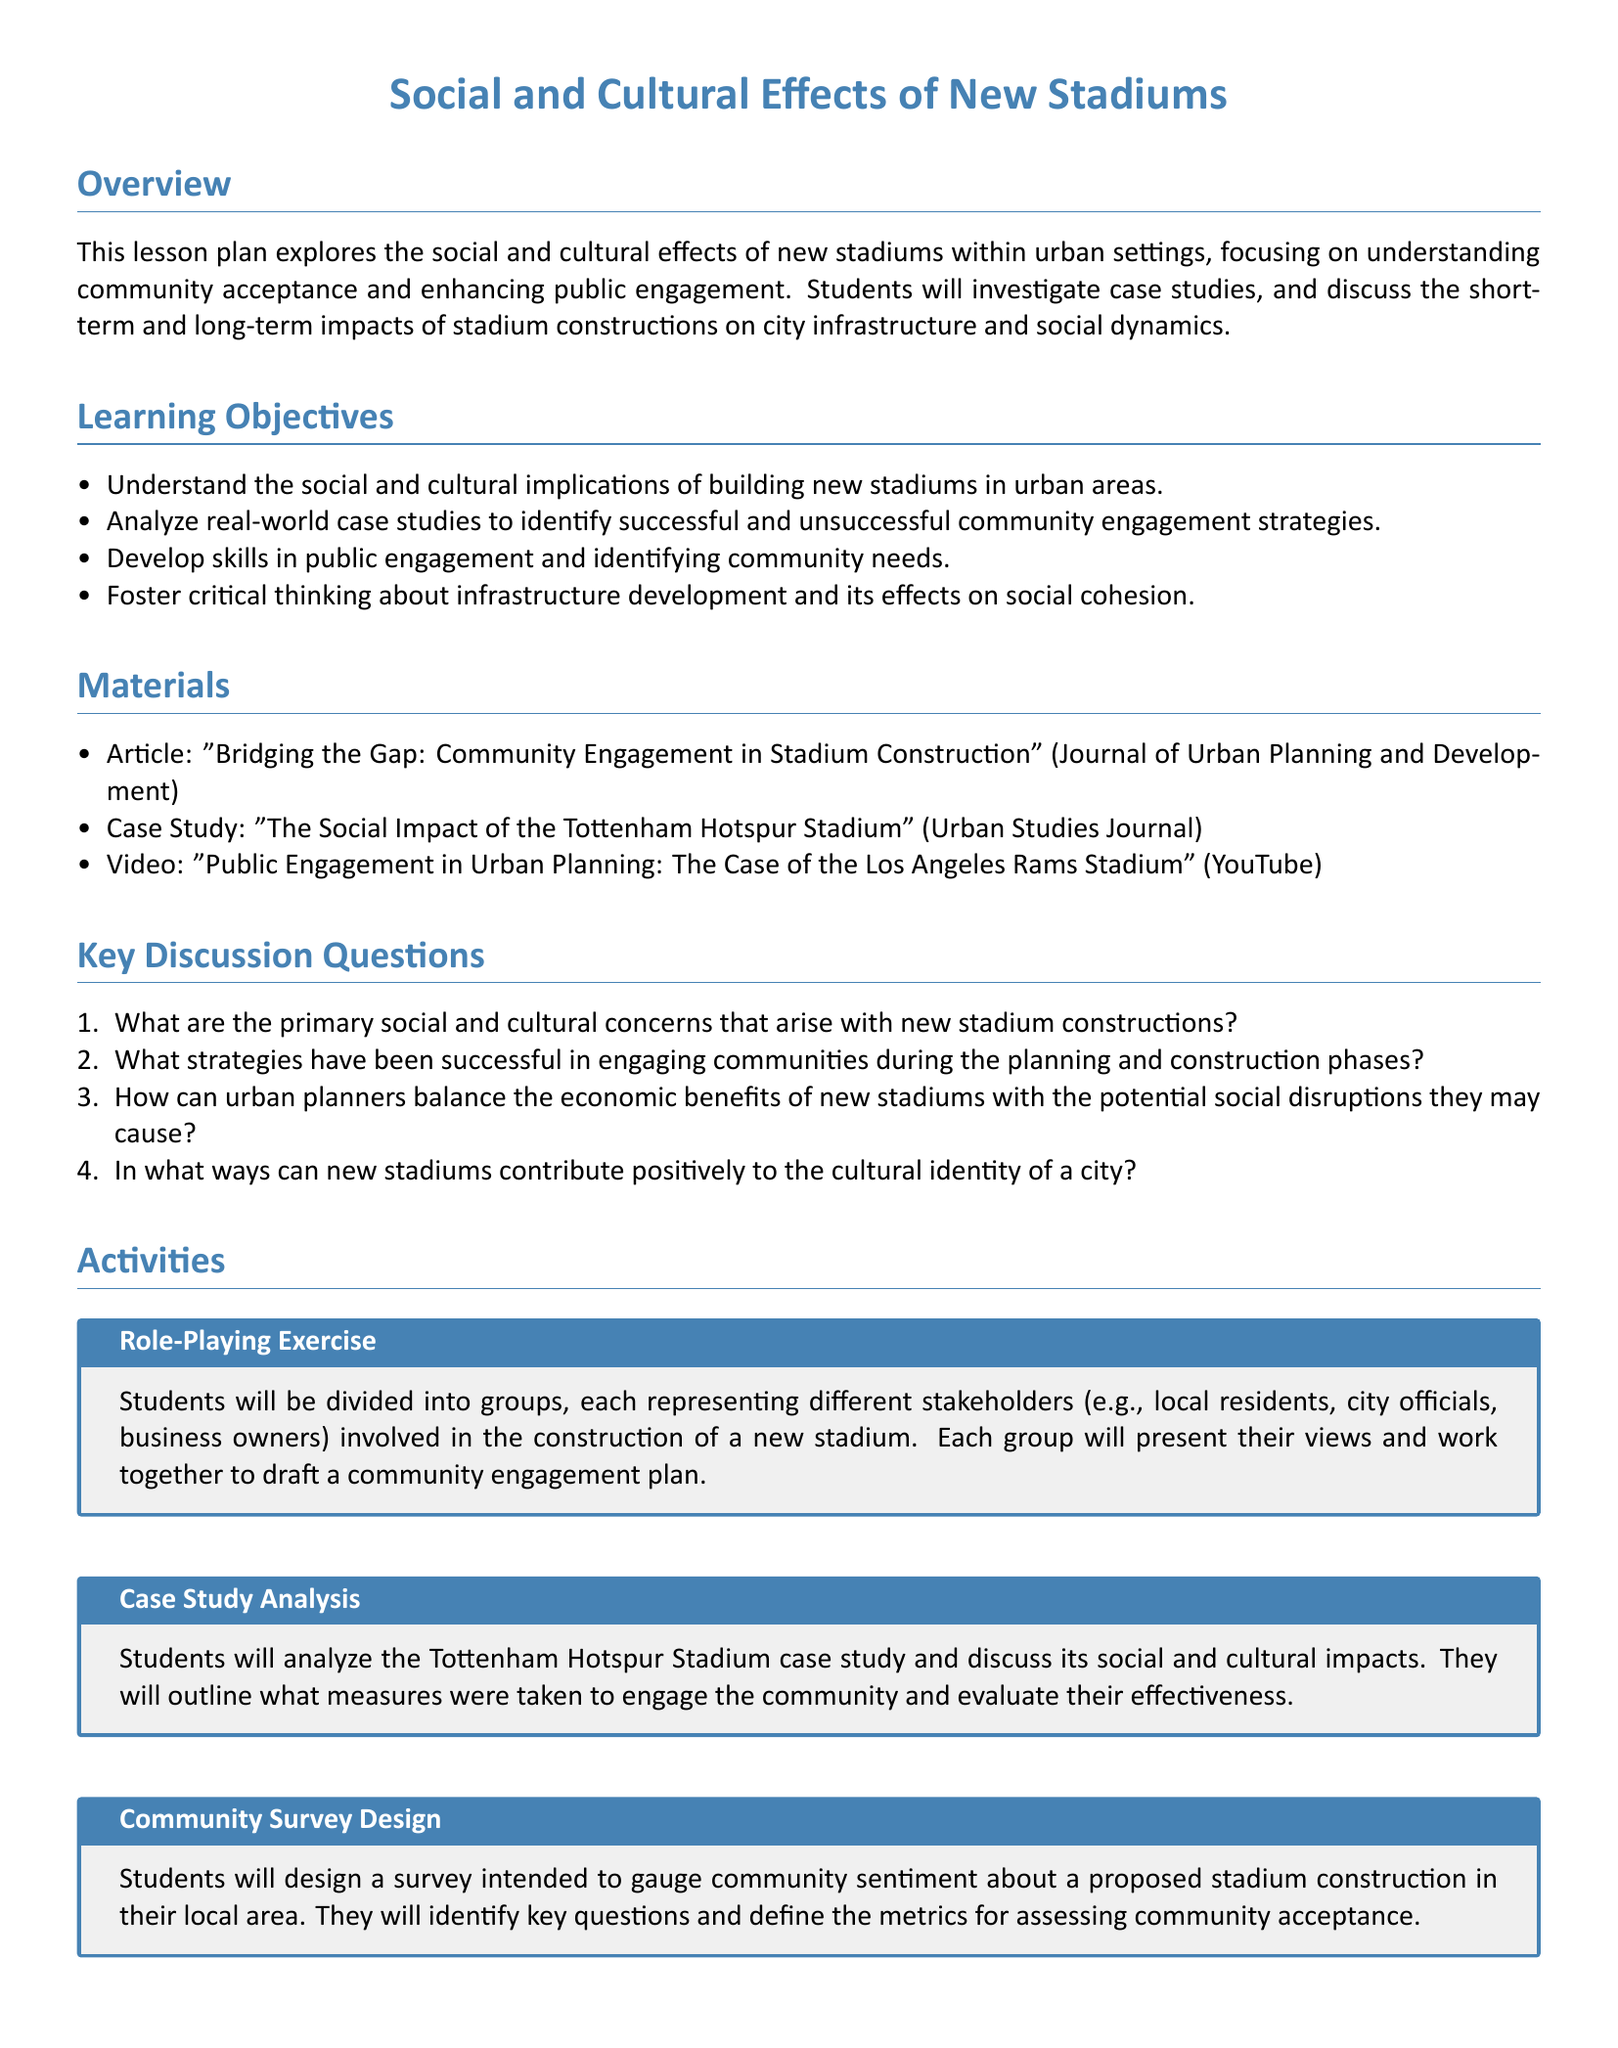What is the title of the lesson plan? The title of the lesson plan is presented at the top of the document, indicating the focus on social and cultural effects of new stadiums.
Answer: Social and Cultural Effects of New Stadiums What is one of the learning objectives? The learning objectives are listed in the document, and one specific objective can be quoted directly from this section.
Answer: Understand the social and cultural implications of building new stadiums in urban areas Name a material used in the lessons. The materials section provides a list of resources, including articles and videos that will be utilized during the lessons.
Answer: Article: "Bridging the Gap: Community Engagement in Stadium Construction" What is one key discussion question? Key discussion questions are provided to stimulate thought and discussion amongst students regarding stadium construction and community engagement.
Answer: What are the primary social and cultural concerns that arise with new stadium constructions? What group activity is proposed in the lesson plan? The activities section outlines various exercises for students, including interactive and analytical components that promote engagement.
Answer: Role-Playing Exercise What stadium serves as a case study in the lesson plan? The lesson plan specifies a particular stadium to analyze its social and cultural implications as part of the coursework.
Answer: Tottenham Hotspur Stadium How many learning objectives are listed in the document? The learning objectives are numbered in the document, and counting them yields the total.
Answer: Four What skills are students expected to develop? The learning objectives include developing specific skills, which are articulated clearly in that section.
Answer: Public engagement and identifying community needs What type of exercise involves community survey design? The activities section includes a specific exercise aimed at understanding community sentiment through the design of surveys.
Answer: Community Survey Design 